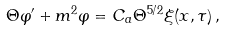Convert formula to latex. <formula><loc_0><loc_0><loc_500><loc_500>\Theta \varphi ^ { \prime } + m ^ { 2 } \varphi = C _ { a } \Theta ^ { 5 / 2 } \xi ( { x } , \tau ) \, ,</formula> 